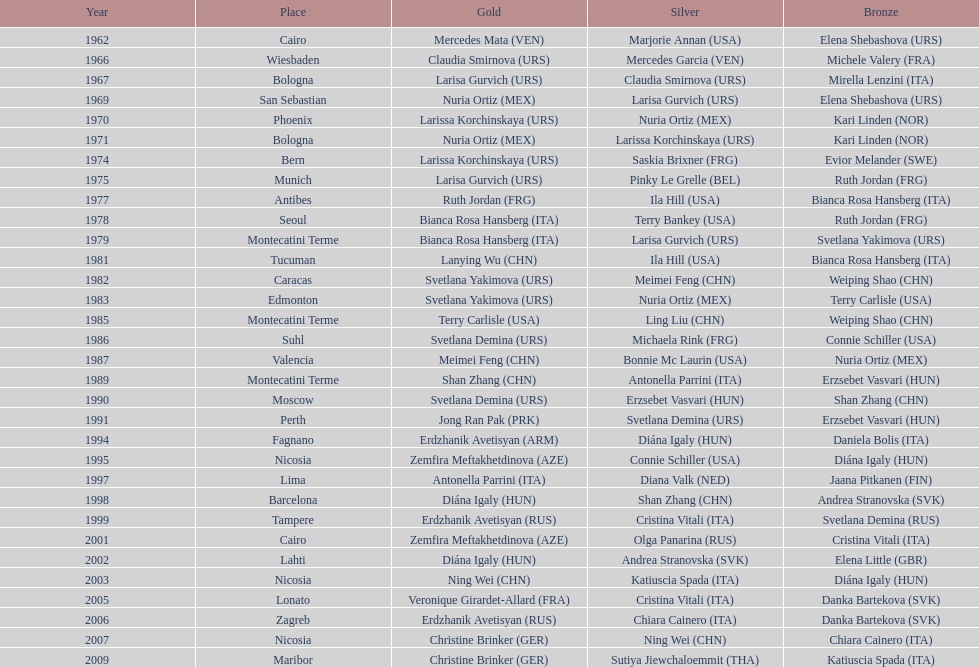Which country holds the record for the most bronze medals? Italy. 